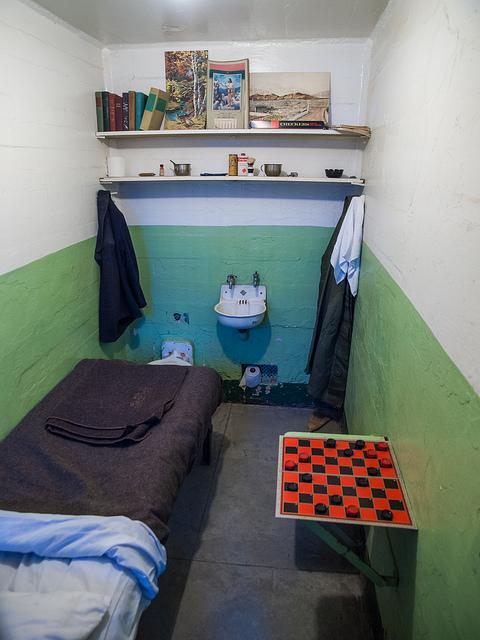Who most likely sleeps here? Please explain your reasoning. prisoner. An inmate stays in this cell. 